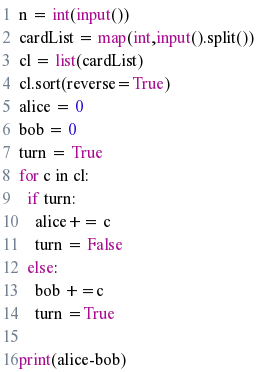Convert code to text. <code><loc_0><loc_0><loc_500><loc_500><_Python_>n = int(input())
cardList = map(int,input().split())
cl = list(cardList)
cl.sort(reverse=True)
alice = 0
bob = 0
turn = True
for c in cl:  
  if turn:
    alice+= c
    turn = False
  else:
    bob +=c
    turn =True
    
print(alice-bob)  </code> 